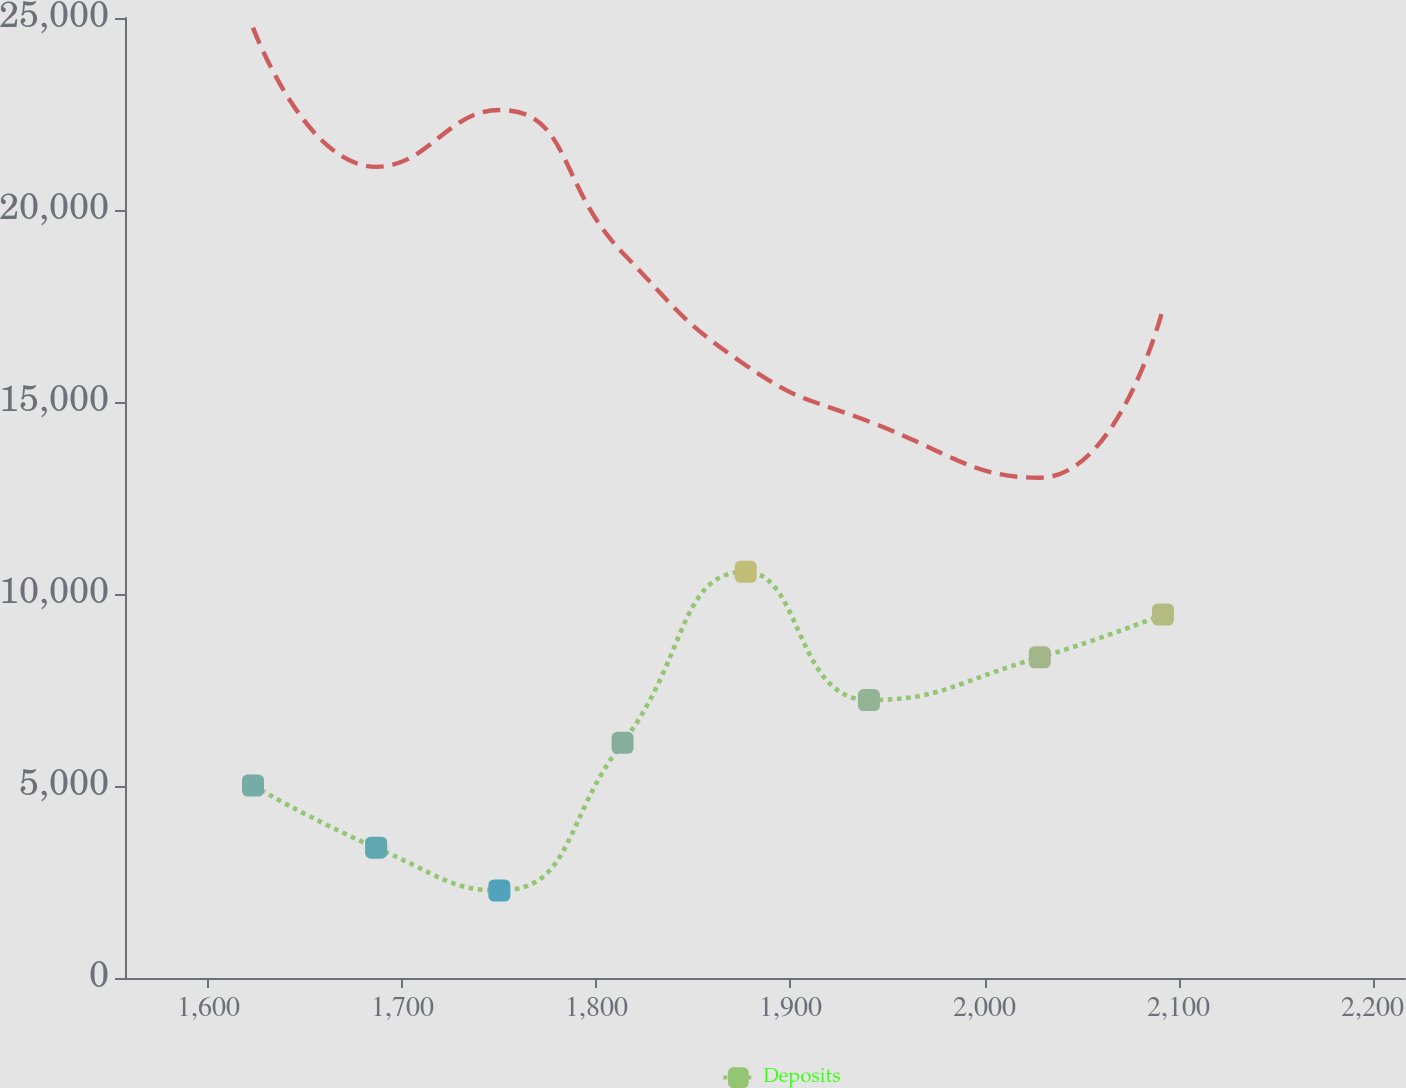Convert chart to OTSL. <chart><loc_0><loc_0><loc_500><loc_500><line_chart><ecel><fcel>Unnamed: 1<fcel>Deposits<nl><fcel>1622.96<fcel>24748.9<fcel>5011.1<nl><fcel>1686.45<fcel>21124.1<fcel>3392.6<nl><fcel>1749.94<fcel>22605.7<fcel>2278.97<nl><fcel>1813.43<fcel>18888.5<fcel>6124.74<nl><fcel>1876.92<fcel>15958.2<fcel>10579.3<nl><fcel>1940.41<fcel>14493.1<fcel>7238.38<nl><fcel>2028.49<fcel>13027.9<fcel>8352.01<nl><fcel>2091.98<fcel>17423.3<fcel>9465.65<nl><fcel>2219.22<fcel>11562.8<fcel>12182.3<nl><fcel>2282.71<fcel>10097.7<fcel>13415.3<nl></chart> 